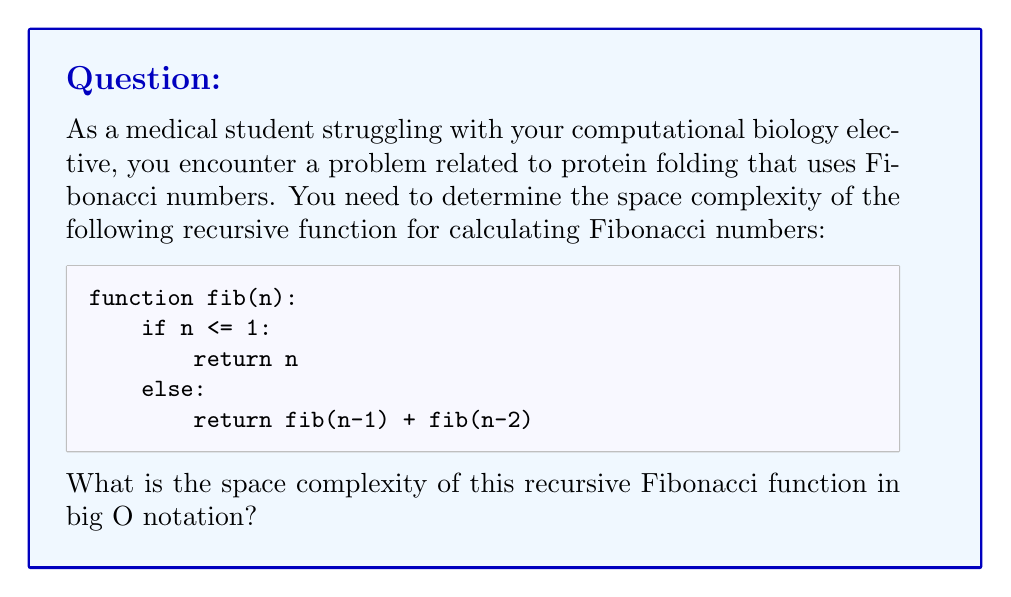What is the answer to this math problem? To determine the space complexity of the recursive Fibonacci function, we need to consider the maximum depth of the recursion stack:

1. Each recursive call creates a new stack frame.
2. The deepest path in the recursion tree occurs when we continuously call fib(n-1) until we reach the base case.
3. The number of recursive calls in this path is equal to n.
4. Each stack frame uses a constant amount of memory (to store the value of n and the return address).

Let's analyze the space usage:

- At any given time, the maximum number of stack frames is n.
- Each stack frame uses O(1) space.
- Therefore, the total space used is n * O(1) = O(n).

It's important to note that this is different from the time complexity, which is O($2^n$) due to the exponential number of function calls.

The space complexity is linear because:

1. We only need to consider the maximum depth of the recursion tree.
2. The width of the tree doesn't affect the space complexity, as we don't store all intermediate results simultaneously.

In the context of your protein folding problem, this means that the memory usage of your algorithm will grow linearly with the size of the input, which is more manageable than its time complexity.
Answer: The space complexity of the recursive Fibonacci function is O(n). 